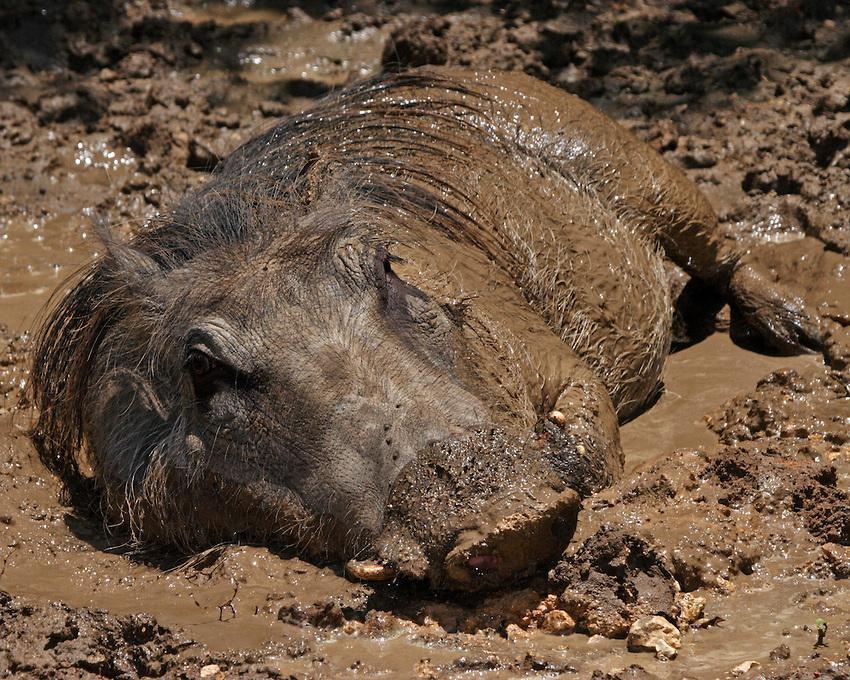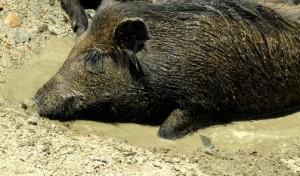The first image is the image on the left, the second image is the image on the right. For the images shown, is this caption "There are two wild boars in mud." true? Answer yes or no. Yes. The first image is the image on the left, the second image is the image on the right. Considering the images on both sides, is "In at least one image there is a hog in the mud whose body is facing left while they rest." valid? Answer yes or no. Yes. 